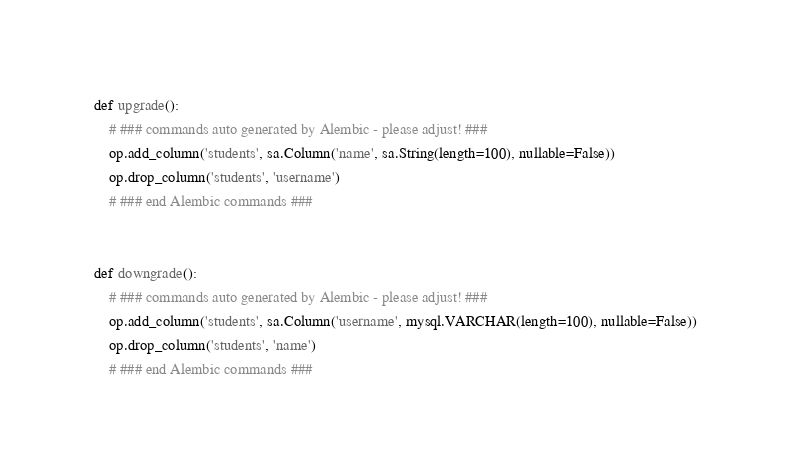<code> <loc_0><loc_0><loc_500><loc_500><_Python_>
def upgrade():
    # ### commands auto generated by Alembic - please adjust! ###
    op.add_column('students', sa.Column('name', sa.String(length=100), nullable=False))
    op.drop_column('students', 'username')
    # ### end Alembic commands ###


def downgrade():
    # ### commands auto generated by Alembic - please adjust! ###
    op.add_column('students', sa.Column('username', mysql.VARCHAR(length=100), nullable=False))
    op.drop_column('students', 'name')
    # ### end Alembic commands ###
</code> 